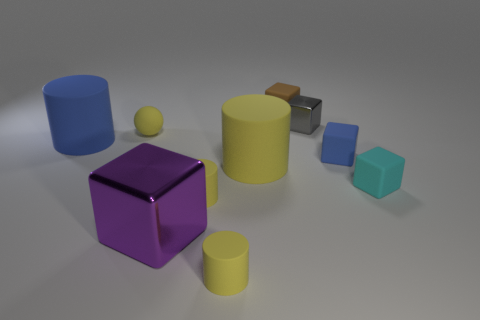Are there any brown rubber objects of the same shape as the cyan object?
Your answer should be compact. Yes. The metallic thing that is to the right of the tiny brown rubber thing behind the blue cube is what shape?
Offer a very short reply. Cube. What number of balls are large yellow objects or tiny brown matte things?
Keep it short and to the point. 0. What is the material of the large thing that is the same color as the rubber ball?
Offer a terse response. Rubber. Is the shape of the blue rubber object that is on the left side of the big purple object the same as the metallic object on the right side of the tiny brown matte cube?
Offer a very short reply. No. What color is the tiny thing that is both behind the small blue thing and in front of the gray cube?
Ensure brevity in your answer.  Yellow. There is a rubber sphere; is its color the same as the metallic object in front of the large blue cylinder?
Ensure brevity in your answer.  No. What is the size of the cube that is left of the gray metallic cube and behind the big blue rubber object?
Your answer should be very brief. Small. How many other objects are the same color as the tiny metallic thing?
Provide a short and direct response. 0. How big is the blue matte object that is on the left side of the rubber ball on the right side of the thing that is left of the yellow sphere?
Keep it short and to the point. Large. 